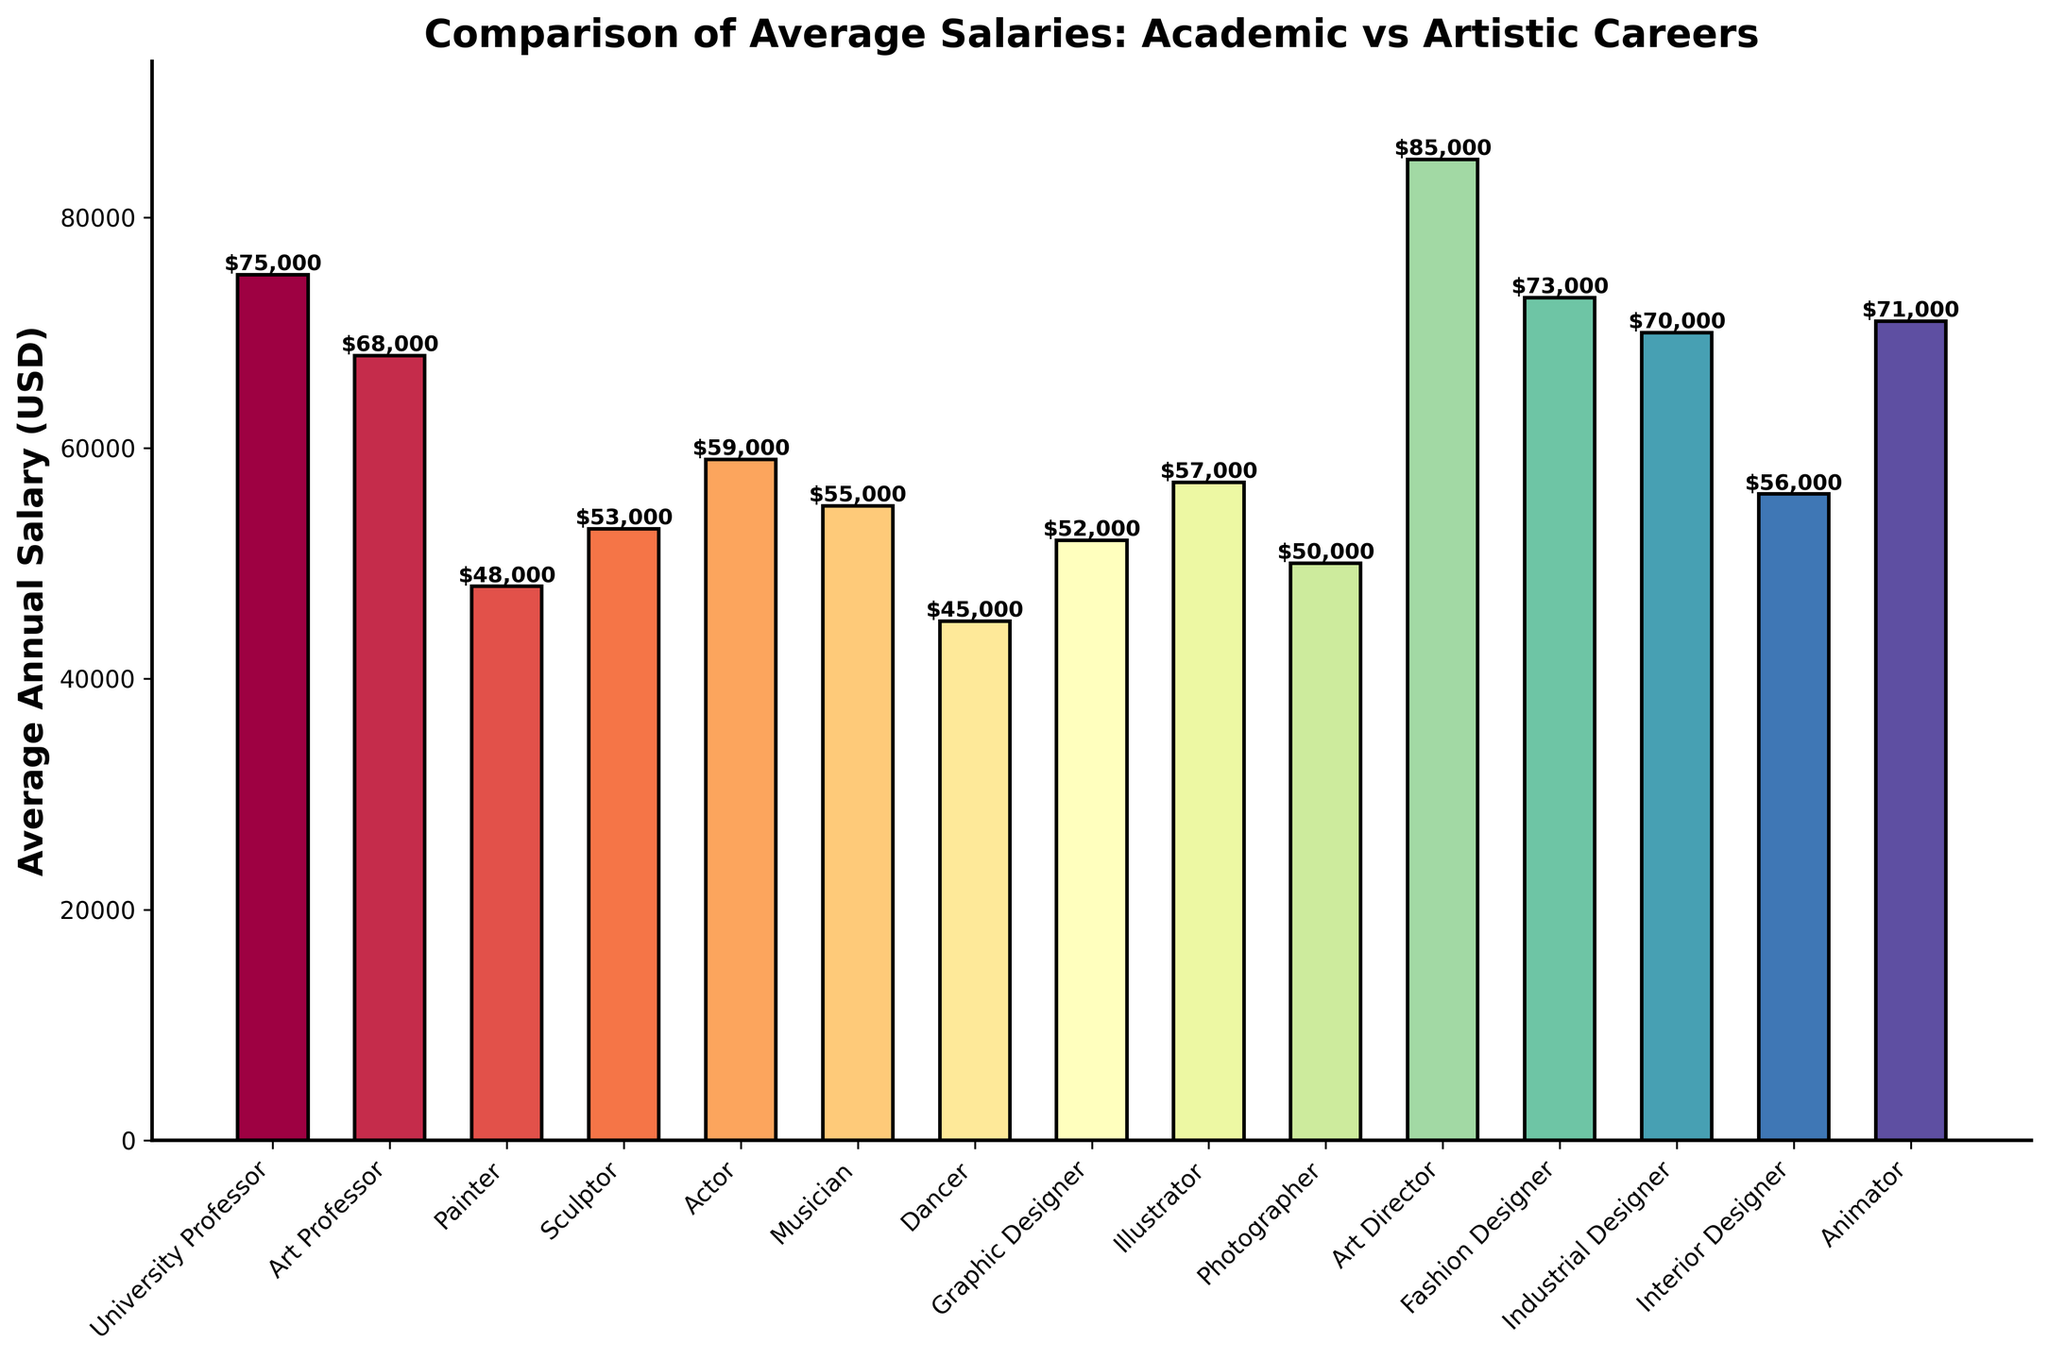What's the highest average annual salary shown on the chart? By scanning the heights of all the bars, it's clear that the "Art Director" bar reaches the highest value.
Answer: $85,000 Which career has a higher average salary, University Professor or Art Professor? Comparing the heights of the bars for "University Professor" and "Art Professor", the "University Professor" bar is taller.
Answer: University Professor What is the difference in average salary between a Painter and an Animator? The average salary for a Painter is $48,000 and for an Animator is $71,000. Subtracting these values gives $71,000 - $48,000.
Answer: $23,000 Order the artistic professions from the highest to lowest average salary. By comparing the heights of all artistic profession bars, the order from highest to lowest is: Art Director ($85,000), Animator ($71,000), Fashion Designer ($73,000), Industrial Designer ($70,000), Actor ($59,000), Musician ($55,000), Interior Designer ($56,000), Illustrator ($57,000), Sculptor ($53,000), Graphic Designer ($52,000), Photographer ($50,000), Painter ($48,000), Dancer ($45,000).
Answer: Art Director > Animator > Fashion Designer > Industrial Designer > Actor > Musician > Interior Designer > Illustrator > Sculptor > Graphic Designer > Photographer > Painter > Dancer What is the combined average salary of a Sculptor, Graphic Designer, and Photographer? Average salaries are: Sculptor ($53,000), Graphic Designer ($52,000), Photographer ($50,000). Summing these values: $53,000 + $52,000 + $50,000 = $155,000.
Answer: $155,000 Which profession among those listed exhibits the smallest average salary and what is it? By identifying the smallest bar, the career with the lowest average salary is "Dancer".
Answer: $45,000 How much higher is the average salary of an Art Director than a Graphic Designer? The average salary for an Art Director is $85,000 and for a Graphic Designer is $52,000. Subtracting these values gives $85,000 - $52,000.
Answer: $33,000 What is the average annual salary of careers listed under traditional academic fields? The average salary for University Professor is $75,000 and for Art Professor is $68,000. The average is calculated by: ($75,000 + $68,000) / 2 = $71,500.
Answer: $71,500 What's the percentage difference in the average salary between an Illustrator and a Painter? The average salary for an Illustrator is $57,000 and for a Painter is $48,000. The difference is calculated by: (57,000 - 48,000) / 48,000 * 100.
Answer: 18.75% 